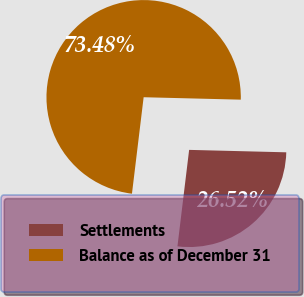<chart> <loc_0><loc_0><loc_500><loc_500><pie_chart><fcel>Settlements<fcel>Balance as of December 31<nl><fcel>26.52%<fcel>73.48%<nl></chart> 